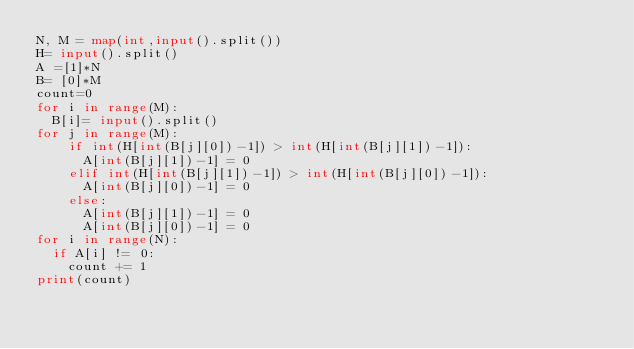Convert code to text. <code><loc_0><loc_0><loc_500><loc_500><_Python_>N, M = map(int,input().split())
H= input().split()
A =[1]*N
B= [0]*M
count=0
for i in range(M):
  B[i]= input().split()
for j in range(M):
    if int(H[int(B[j][0])-1]) > int(H[int(B[j][1])-1]):
      A[int(B[j][1])-1] = 0
    elif int(H[int(B[j][1])-1]) > int(H[int(B[j][0])-1]):
      A[int(B[j][0])-1] = 0
    else:
      A[int(B[j][1])-1] = 0
      A[int(B[j][0])-1] = 0
for i in range(N):
  if A[i] != 0:
    count += 1
print(count)
       
        </code> 